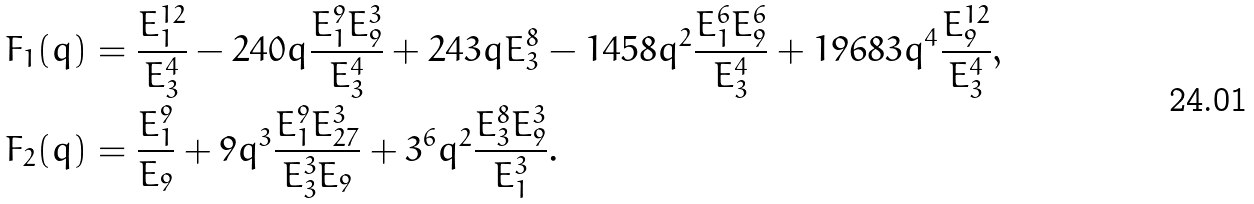Convert formula to latex. <formula><loc_0><loc_0><loc_500><loc_500>F _ { 1 } ( q ) & = \frac { E _ { 1 } ^ { 1 2 } } { E _ { 3 } ^ { 4 } } - 2 4 0 q \frac { E _ { 1 } ^ { 9 } E _ { 9 } ^ { 3 } } { E _ { 3 } ^ { 4 } } + 2 4 3 q E _ { 3 } ^ { 8 } - 1 4 5 8 q ^ { 2 } \frac { E _ { 1 } ^ { 6 } E _ { 9 } ^ { 6 } } { E _ { 3 } ^ { 4 } } + 1 9 6 8 3 q ^ { 4 } \frac { E _ { 9 } ^ { 1 2 } } { E _ { 3 } ^ { 4 } } , \\ F _ { 2 } ( q ) & = \frac { E _ { 1 } ^ { 9 } } { E _ { 9 } } + 9 q ^ { 3 } \frac { E _ { 1 } ^ { 9 } E _ { 2 7 } ^ { 3 } } { E _ { 3 } ^ { 3 } E _ { 9 } } + 3 ^ { 6 } q ^ { 2 } \frac { E _ { 3 } ^ { 8 } E _ { 9 } ^ { 3 } } { E _ { 1 } ^ { 3 } } .</formula> 